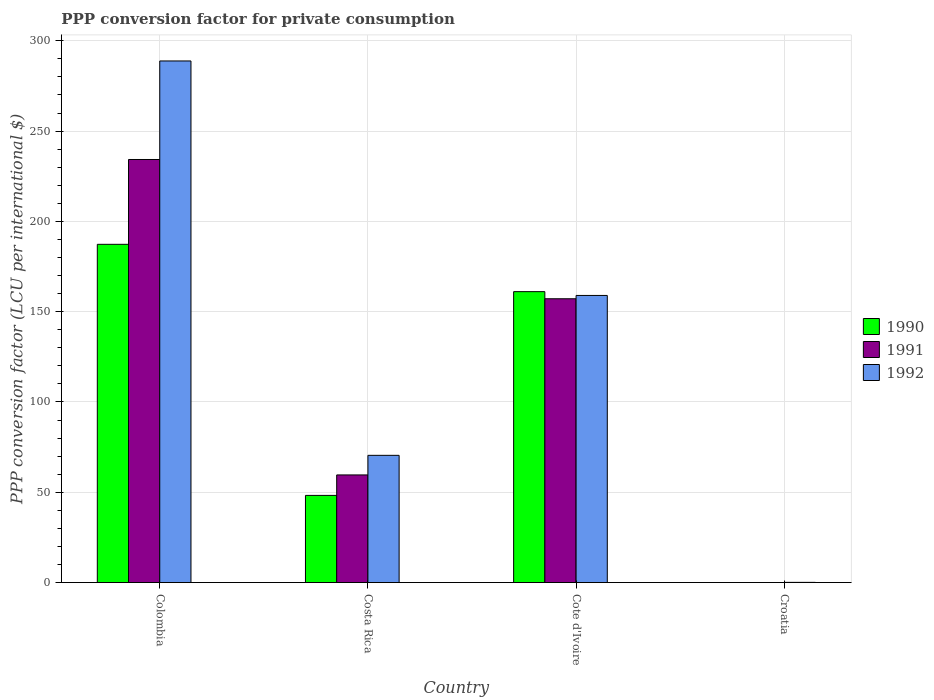How many different coloured bars are there?
Make the answer very short. 3. How many bars are there on the 1st tick from the left?
Your answer should be very brief. 3. What is the label of the 4th group of bars from the left?
Provide a succinct answer. Croatia. What is the PPP conversion factor for private consumption in 1992 in Croatia?
Provide a short and direct response. 0.12. Across all countries, what is the maximum PPP conversion factor for private consumption in 1991?
Make the answer very short. 234.26. Across all countries, what is the minimum PPP conversion factor for private consumption in 1990?
Keep it short and to the point. 0.01. In which country was the PPP conversion factor for private consumption in 1991 maximum?
Make the answer very short. Colombia. In which country was the PPP conversion factor for private consumption in 1992 minimum?
Make the answer very short. Croatia. What is the total PPP conversion factor for private consumption in 1990 in the graph?
Give a very brief answer. 396.67. What is the difference between the PPP conversion factor for private consumption in 1990 in Cote d'Ivoire and that in Croatia?
Your answer should be compact. 161.08. What is the difference between the PPP conversion factor for private consumption in 1991 in Colombia and the PPP conversion factor for private consumption in 1992 in Costa Rica?
Make the answer very short. 163.8. What is the average PPP conversion factor for private consumption in 1992 per country?
Offer a terse response. 129.59. What is the difference between the PPP conversion factor for private consumption of/in 1992 and PPP conversion factor for private consumption of/in 1990 in Colombia?
Give a very brief answer. 101.52. What is the ratio of the PPP conversion factor for private consumption in 1990 in Colombia to that in Cote d'Ivoire?
Offer a terse response. 1.16. What is the difference between the highest and the second highest PPP conversion factor for private consumption in 1990?
Your response must be concise. -112.82. What is the difference between the highest and the lowest PPP conversion factor for private consumption in 1990?
Offer a terse response. 187.29. In how many countries, is the PPP conversion factor for private consumption in 1992 greater than the average PPP conversion factor for private consumption in 1992 taken over all countries?
Offer a very short reply. 2. How many bars are there?
Make the answer very short. 12. Are all the bars in the graph horizontal?
Offer a terse response. No. What is the difference between two consecutive major ticks on the Y-axis?
Provide a succinct answer. 50. Are the values on the major ticks of Y-axis written in scientific E-notation?
Your answer should be compact. No. Does the graph contain any zero values?
Offer a very short reply. No. Where does the legend appear in the graph?
Keep it short and to the point. Center right. How many legend labels are there?
Keep it short and to the point. 3. What is the title of the graph?
Ensure brevity in your answer.  PPP conversion factor for private consumption. Does "1965" appear as one of the legend labels in the graph?
Provide a succinct answer. No. What is the label or title of the Y-axis?
Provide a short and direct response. PPP conversion factor (LCU per international $). What is the PPP conversion factor (LCU per international $) of 1990 in Colombia?
Provide a succinct answer. 187.29. What is the PPP conversion factor (LCU per international $) in 1991 in Colombia?
Provide a succinct answer. 234.26. What is the PPP conversion factor (LCU per international $) of 1992 in Colombia?
Offer a very short reply. 288.82. What is the PPP conversion factor (LCU per international $) in 1990 in Costa Rica?
Offer a very short reply. 48.27. What is the PPP conversion factor (LCU per international $) of 1991 in Costa Rica?
Your response must be concise. 59.61. What is the PPP conversion factor (LCU per international $) in 1992 in Costa Rica?
Provide a short and direct response. 70.46. What is the PPP conversion factor (LCU per international $) in 1990 in Cote d'Ivoire?
Ensure brevity in your answer.  161.09. What is the PPP conversion factor (LCU per international $) of 1991 in Cote d'Ivoire?
Ensure brevity in your answer.  157.15. What is the PPP conversion factor (LCU per international $) in 1992 in Cote d'Ivoire?
Keep it short and to the point. 158.98. What is the PPP conversion factor (LCU per international $) in 1990 in Croatia?
Your answer should be very brief. 0.01. What is the PPP conversion factor (LCU per international $) of 1991 in Croatia?
Your answer should be very brief. 0.02. What is the PPP conversion factor (LCU per international $) in 1992 in Croatia?
Offer a very short reply. 0.12. Across all countries, what is the maximum PPP conversion factor (LCU per international $) in 1990?
Keep it short and to the point. 187.29. Across all countries, what is the maximum PPP conversion factor (LCU per international $) in 1991?
Your response must be concise. 234.26. Across all countries, what is the maximum PPP conversion factor (LCU per international $) in 1992?
Your response must be concise. 288.82. Across all countries, what is the minimum PPP conversion factor (LCU per international $) of 1990?
Your response must be concise. 0.01. Across all countries, what is the minimum PPP conversion factor (LCU per international $) of 1991?
Provide a succinct answer. 0.02. Across all countries, what is the minimum PPP conversion factor (LCU per international $) of 1992?
Your response must be concise. 0.12. What is the total PPP conversion factor (LCU per international $) of 1990 in the graph?
Your response must be concise. 396.67. What is the total PPP conversion factor (LCU per international $) of 1991 in the graph?
Give a very brief answer. 451.03. What is the total PPP conversion factor (LCU per international $) in 1992 in the graph?
Give a very brief answer. 518.38. What is the difference between the PPP conversion factor (LCU per international $) in 1990 in Colombia and that in Costa Rica?
Give a very brief answer. 139.02. What is the difference between the PPP conversion factor (LCU per international $) in 1991 in Colombia and that in Costa Rica?
Offer a terse response. 174.65. What is the difference between the PPP conversion factor (LCU per international $) of 1992 in Colombia and that in Costa Rica?
Make the answer very short. 218.36. What is the difference between the PPP conversion factor (LCU per international $) in 1990 in Colombia and that in Cote d'Ivoire?
Give a very brief answer. 26.2. What is the difference between the PPP conversion factor (LCU per international $) in 1991 in Colombia and that in Cote d'Ivoire?
Ensure brevity in your answer.  77.11. What is the difference between the PPP conversion factor (LCU per international $) in 1992 in Colombia and that in Cote d'Ivoire?
Your answer should be very brief. 129.83. What is the difference between the PPP conversion factor (LCU per international $) in 1990 in Colombia and that in Croatia?
Offer a very short reply. 187.29. What is the difference between the PPP conversion factor (LCU per international $) of 1991 in Colombia and that in Croatia?
Keep it short and to the point. 234.24. What is the difference between the PPP conversion factor (LCU per international $) in 1992 in Colombia and that in Croatia?
Offer a terse response. 288.7. What is the difference between the PPP conversion factor (LCU per international $) in 1990 in Costa Rica and that in Cote d'Ivoire?
Your answer should be very brief. -112.82. What is the difference between the PPP conversion factor (LCU per international $) of 1991 in Costa Rica and that in Cote d'Ivoire?
Your response must be concise. -97.54. What is the difference between the PPP conversion factor (LCU per international $) in 1992 in Costa Rica and that in Cote d'Ivoire?
Make the answer very short. -88.52. What is the difference between the PPP conversion factor (LCU per international $) of 1990 in Costa Rica and that in Croatia?
Your response must be concise. 48.26. What is the difference between the PPP conversion factor (LCU per international $) of 1991 in Costa Rica and that in Croatia?
Your response must be concise. 59.59. What is the difference between the PPP conversion factor (LCU per international $) in 1992 in Costa Rica and that in Croatia?
Your response must be concise. 70.34. What is the difference between the PPP conversion factor (LCU per international $) in 1990 in Cote d'Ivoire and that in Croatia?
Make the answer very short. 161.08. What is the difference between the PPP conversion factor (LCU per international $) in 1991 in Cote d'Ivoire and that in Croatia?
Provide a short and direct response. 157.13. What is the difference between the PPP conversion factor (LCU per international $) in 1992 in Cote d'Ivoire and that in Croatia?
Keep it short and to the point. 158.86. What is the difference between the PPP conversion factor (LCU per international $) in 1990 in Colombia and the PPP conversion factor (LCU per international $) in 1991 in Costa Rica?
Offer a terse response. 127.69. What is the difference between the PPP conversion factor (LCU per international $) in 1990 in Colombia and the PPP conversion factor (LCU per international $) in 1992 in Costa Rica?
Make the answer very short. 116.83. What is the difference between the PPP conversion factor (LCU per international $) of 1991 in Colombia and the PPP conversion factor (LCU per international $) of 1992 in Costa Rica?
Ensure brevity in your answer.  163.8. What is the difference between the PPP conversion factor (LCU per international $) of 1990 in Colombia and the PPP conversion factor (LCU per international $) of 1991 in Cote d'Ivoire?
Make the answer very short. 30.15. What is the difference between the PPP conversion factor (LCU per international $) in 1990 in Colombia and the PPP conversion factor (LCU per international $) in 1992 in Cote d'Ivoire?
Your response must be concise. 28.31. What is the difference between the PPP conversion factor (LCU per international $) of 1991 in Colombia and the PPP conversion factor (LCU per international $) of 1992 in Cote d'Ivoire?
Ensure brevity in your answer.  75.28. What is the difference between the PPP conversion factor (LCU per international $) in 1990 in Colombia and the PPP conversion factor (LCU per international $) in 1991 in Croatia?
Give a very brief answer. 187.28. What is the difference between the PPP conversion factor (LCU per international $) of 1990 in Colombia and the PPP conversion factor (LCU per international $) of 1992 in Croatia?
Offer a very short reply. 187.17. What is the difference between the PPP conversion factor (LCU per international $) of 1991 in Colombia and the PPP conversion factor (LCU per international $) of 1992 in Croatia?
Your answer should be compact. 234.14. What is the difference between the PPP conversion factor (LCU per international $) of 1990 in Costa Rica and the PPP conversion factor (LCU per international $) of 1991 in Cote d'Ivoire?
Provide a short and direct response. -108.88. What is the difference between the PPP conversion factor (LCU per international $) in 1990 in Costa Rica and the PPP conversion factor (LCU per international $) in 1992 in Cote d'Ivoire?
Offer a terse response. -110.71. What is the difference between the PPP conversion factor (LCU per international $) of 1991 in Costa Rica and the PPP conversion factor (LCU per international $) of 1992 in Cote d'Ivoire?
Provide a succinct answer. -99.38. What is the difference between the PPP conversion factor (LCU per international $) in 1990 in Costa Rica and the PPP conversion factor (LCU per international $) in 1991 in Croatia?
Offer a very short reply. 48.26. What is the difference between the PPP conversion factor (LCU per international $) in 1990 in Costa Rica and the PPP conversion factor (LCU per international $) in 1992 in Croatia?
Offer a very short reply. 48.15. What is the difference between the PPP conversion factor (LCU per international $) of 1991 in Costa Rica and the PPP conversion factor (LCU per international $) of 1992 in Croatia?
Provide a short and direct response. 59.49. What is the difference between the PPP conversion factor (LCU per international $) of 1990 in Cote d'Ivoire and the PPP conversion factor (LCU per international $) of 1991 in Croatia?
Keep it short and to the point. 161.07. What is the difference between the PPP conversion factor (LCU per international $) of 1990 in Cote d'Ivoire and the PPP conversion factor (LCU per international $) of 1992 in Croatia?
Ensure brevity in your answer.  160.97. What is the difference between the PPP conversion factor (LCU per international $) in 1991 in Cote d'Ivoire and the PPP conversion factor (LCU per international $) in 1992 in Croatia?
Offer a terse response. 157.03. What is the average PPP conversion factor (LCU per international $) in 1990 per country?
Ensure brevity in your answer.  99.17. What is the average PPP conversion factor (LCU per international $) of 1991 per country?
Provide a short and direct response. 112.76. What is the average PPP conversion factor (LCU per international $) of 1992 per country?
Your response must be concise. 129.59. What is the difference between the PPP conversion factor (LCU per international $) in 1990 and PPP conversion factor (LCU per international $) in 1991 in Colombia?
Provide a short and direct response. -46.97. What is the difference between the PPP conversion factor (LCU per international $) in 1990 and PPP conversion factor (LCU per international $) in 1992 in Colombia?
Offer a terse response. -101.52. What is the difference between the PPP conversion factor (LCU per international $) of 1991 and PPP conversion factor (LCU per international $) of 1992 in Colombia?
Your answer should be compact. -54.56. What is the difference between the PPP conversion factor (LCU per international $) of 1990 and PPP conversion factor (LCU per international $) of 1991 in Costa Rica?
Make the answer very short. -11.33. What is the difference between the PPP conversion factor (LCU per international $) in 1990 and PPP conversion factor (LCU per international $) in 1992 in Costa Rica?
Offer a very short reply. -22.19. What is the difference between the PPP conversion factor (LCU per international $) of 1991 and PPP conversion factor (LCU per international $) of 1992 in Costa Rica?
Your response must be concise. -10.85. What is the difference between the PPP conversion factor (LCU per international $) of 1990 and PPP conversion factor (LCU per international $) of 1991 in Cote d'Ivoire?
Make the answer very short. 3.94. What is the difference between the PPP conversion factor (LCU per international $) in 1990 and PPP conversion factor (LCU per international $) in 1992 in Cote d'Ivoire?
Offer a terse response. 2.11. What is the difference between the PPP conversion factor (LCU per international $) in 1991 and PPP conversion factor (LCU per international $) in 1992 in Cote d'Ivoire?
Ensure brevity in your answer.  -1.83. What is the difference between the PPP conversion factor (LCU per international $) in 1990 and PPP conversion factor (LCU per international $) in 1991 in Croatia?
Your answer should be compact. -0.01. What is the difference between the PPP conversion factor (LCU per international $) of 1990 and PPP conversion factor (LCU per international $) of 1992 in Croatia?
Provide a short and direct response. -0.11. What is the difference between the PPP conversion factor (LCU per international $) in 1991 and PPP conversion factor (LCU per international $) in 1992 in Croatia?
Give a very brief answer. -0.1. What is the ratio of the PPP conversion factor (LCU per international $) in 1990 in Colombia to that in Costa Rica?
Keep it short and to the point. 3.88. What is the ratio of the PPP conversion factor (LCU per international $) of 1991 in Colombia to that in Costa Rica?
Provide a succinct answer. 3.93. What is the ratio of the PPP conversion factor (LCU per international $) of 1992 in Colombia to that in Costa Rica?
Offer a terse response. 4.1. What is the ratio of the PPP conversion factor (LCU per international $) of 1990 in Colombia to that in Cote d'Ivoire?
Offer a very short reply. 1.16. What is the ratio of the PPP conversion factor (LCU per international $) of 1991 in Colombia to that in Cote d'Ivoire?
Ensure brevity in your answer.  1.49. What is the ratio of the PPP conversion factor (LCU per international $) of 1992 in Colombia to that in Cote d'Ivoire?
Offer a very short reply. 1.82. What is the ratio of the PPP conversion factor (LCU per international $) in 1990 in Colombia to that in Croatia?
Offer a terse response. 2.34e+04. What is the ratio of the PPP conversion factor (LCU per international $) in 1991 in Colombia to that in Croatia?
Your answer should be compact. 1.37e+04. What is the ratio of the PPP conversion factor (LCU per international $) in 1992 in Colombia to that in Croatia?
Your response must be concise. 2403.57. What is the ratio of the PPP conversion factor (LCU per international $) in 1990 in Costa Rica to that in Cote d'Ivoire?
Your response must be concise. 0.3. What is the ratio of the PPP conversion factor (LCU per international $) in 1991 in Costa Rica to that in Cote d'Ivoire?
Your response must be concise. 0.38. What is the ratio of the PPP conversion factor (LCU per international $) of 1992 in Costa Rica to that in Cote d'Ivoire?
Offer a terse response. 0.44. What is the ratio of the PPP conversion factor (LCU per international $) of 1990 in Costa Rica to that in Croatia?
Your answer should be very brief. 6026.83. What is the ratio of the PPP conversion factor (LCU per international $) of 1991 in Costa Rica to that in Croatia?
Your answer should be very brief. 3490.69. What is the ratio of the PPP conversion factor (LCU per international $) of 1992 in Costa Rica to that in Croatia?
Keep it short and to the point. 586.38. What is the ratio of the PPP conversion factor (LCU per international $) of 1990 in Cote d'Ivoire to that in Croatia?
Your response must be concise. 2.01e+04. What is the ratio of the PPP conversion factor (LCU per international $) in 1991 in Cote d'Ivoire to that in Croatia?
Ensure brevity in your answer.  9202.86. What is the ratio of the PPP conversion factor (LCU per international $) of 1992 in Cote d'Ivoire to that in Croatia?
Make the answer very short. 1323.07. What is the difference between the highest and the second highest PPP conversion factor (LCU per international $) of 1990?
Your response must be concise. 26.2. What is the difference between the highest and the second highest PPP conversion factor (LCU per international $) of 1991?
Your response must be concise. 77.11. What is the difference between the highest and the second highest PPP conversion factor (LCU per international $) of 1992?
Make the answer very short. 129.83. What is the difference between the highest and the lowest PPP conversion factor (LCU per international $) in 1990?
Offer a terse response. 187.29. What is the difference between the highest and the lowest PPP conversion factor (LCU per international $) of 1991?
Your response must be concise. 234.24. What is the difference between the highest and the lowest PPP conversion factor (LCU per international $) of 1992?
Offer a very short reply. 288.7. 